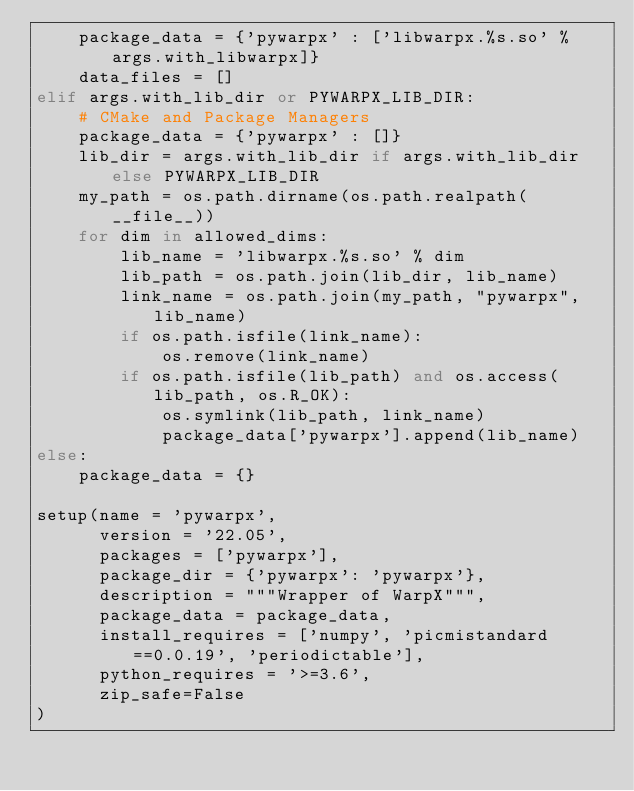Convert code to text. <code><loc_0><loc_0><loc_500><loc_500><_Python_>    package_data = {'pywarpx' : ['libwarpx.%s.so' % args.with_libwarpx]}
    data_files = []
elif args.with_lib_dir or PYWARPX_LIB_DIR:
    # CMake and Package Managers
    package_data = {'pywarpx' : []}
    lib_dir = args.with_lib_dir if args.with_lib_dir else PYWARPX_LIB_DIR
    my_path = os.path.dirname(os.path.realpath(__file__))
    for dim in allowed_dims:
        lib_name = 'libwarpx.%s.so' % dim
        lib_path = os.path.join(lib_dir, lib_name)
        link_name = os.path.join(my_path, "pywarpx", lib_name)
        if os.path.isfile(link_name):
            os.remove(link_name)
        if os.path.isfile(lib_path) and os.access(lib_path, os.R_OK):
            os.symlink(lib_path, link_name)
            package_data['pywarpx'].append(lib_name)
else:
    package_data = {}

setup(name = 'pywarpx',
      version = '22.05',
      packages = ['pywarpx'],
      package_dir = {'pywarpx': 'pywarpx'},
      description = """Wrapper of WarpX""",
      package_data = package_data,
      install_requires = ['numpy', 'picmistandard==0.0.19', 'periodictable'],
      python_requires = '>=3.6',
      zip_safe=False
)
</code> 